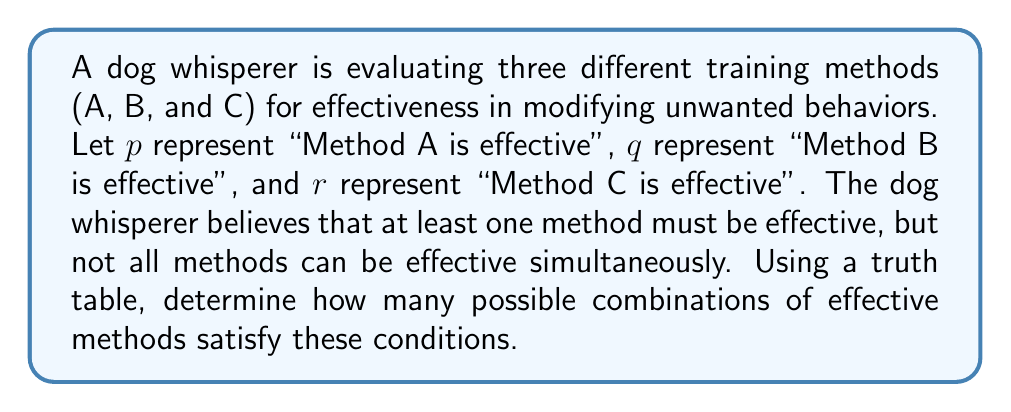Help me with this question. To solve this problem, we need to create a truth table and analyze the combinations that satisfy the given conditions. Let's break it down step-by-step:

1. Create a truth table with 3 variables (p, q, r):

   $$\begin{array}{|c|c|c|c|}
   \hline
   p & q & r & \text{Result} \\
   \hline
   T & T & T & \\
   T & T & F & \\
   T & F & T & \\
   T & F & F & \\
   F & T & T & \\
   F & T & F & \\
   F & F & T & \\
   F & F & F & \\
   \hline
   \end{array}$$

2. Apply the conditions:
   a. At least one method must be effective: $p \lor q \lor r$
   b. Not all methods can be effective simultaneously: $\neg(p \land q \land r)$

3. Combine these conditions: $(p \lor q \lor r) \land \neg(p \land q \land r)$

4. Evaluate each row of the truth table:

   $$\begin{array}{|c|c|c|c|}
   \hline
   p & q & r & (p \lor q \lor r) \land \neg(p \land q \land r) \\
   \hline
   T & T & T & F \\
   T & T & F & T \\
   T & F & T & T \\
   T & F & F & T \\
   F & T & T & T \\
   F & T & F & T \\
   F & F & T & T \\
   F & F & F & F \\
   \hline
   \end{array}$$

5. Count the number of true results in the last column.

There are 6 rows that satisfy the conditions (marked as T in the Result column).
Answer: There are 6 possible combinations of effective methods that satisfy the given conditions. 